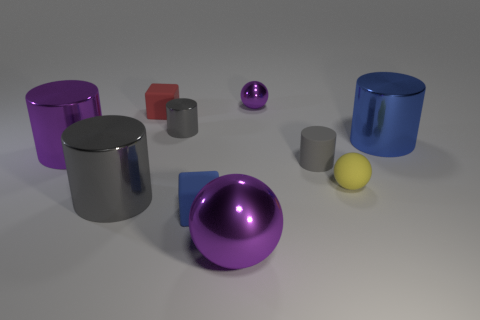Subtract all brown blocks. How many gray cylinders are left? 3 Subtract all gray rubber cylinders. How many cylinders are left? 4 Subtract all blue cylinders. How many cylinders are left? 4 Subtract 1 cylinders. How many cylinders are left? 4 Subtract all green cylinders. Subtract all gray balls. How many cylinders are left? 5 Subtract all balls. How many objects are left? 7 Add 5 metal cylinders. How many metal cylinders are left? 9 Add 3 small gray shiny balls. How many small gray shiny balls exist? 3 Subtract 0 red balls. How many objects are left? 10 Subtract all big yellow matte cylinders. Subtract all big blue things. How many objects are left? 9 